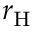Convert formula to latex. <formula><loc_0><loc_0><loc_500><loc_500>r _ { H }</formula> 